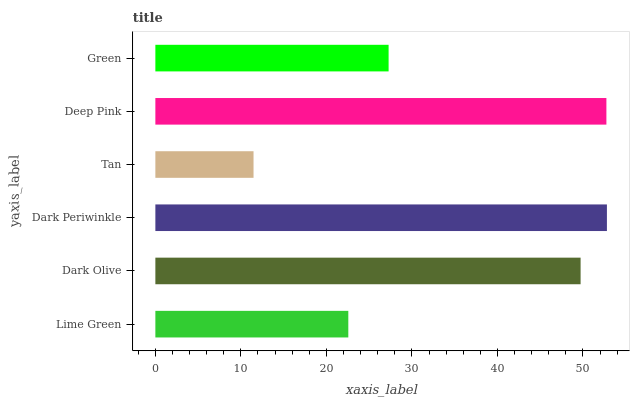Is Tan the minimum?
Answer yes or no. Yes. Is Dark Periwinkle the maximum?
Answer yes or no. Yes. Is Dark Olive the minimum?
Answer yes or no. No. Is Dark Olive the maximum?
Answer yes or no. No. Is Dark Olive greater than Lime Green?
Answer yes or no. Yes. Is Lime Green less than Dark Olive?
Answer yes or no. Yes. Is Lime Green greater than Dark Olive?
Answer yes or no. No. Is Dark Olive less than Lime Green?
Answer yes or no. No. Is Dark Olive the high median?
Answer yes or no. Yes. Is Green the low median?
Answer yes or no. Yes. Is Green the high median?
Answer yes or no. No. Is Dark Olive the low median?
Answer yes or no. No. 